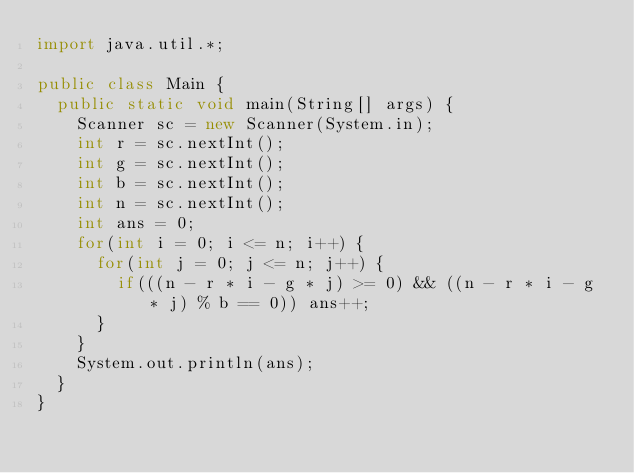<code> <loc_0><loc_0><loc_500><loc_500><_Java_>import java.util.*;

public class Main {
  public static void main(String[] args) {
    Scanner sc = new Scanner(System.in);
    int r = sc.nextInt();
    int g = sc.nextInt();
    int b = sc.nextInt();
    int n = sc.nextInt();
    int ans = 0;
    for(int i = 0; i <= n; i++) {
      for(int j = 0; j <= n; j++) {
        if(((n - r * i - g * j) >= 0) && ((n - r * i - g * j) % b == 0)) ans++;
      }
    }
    System.out.println(ans);
  }
}
</code> 